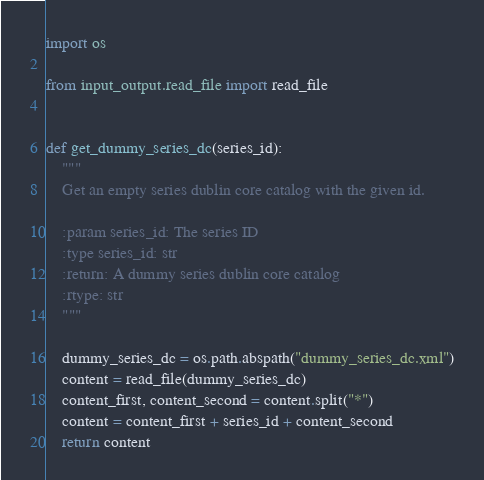<code> <loc_0><loc_0><loc_500><loc_500><_Python_>import os

from input_output.read_file import read_file


def get_dummy_series_dc(series_id):
    """
    Get an empty series dublin core catalog with the given id.

    :param series_id: The series ID
    :type series_id: str
    :return: A dummy series dublin core catalog
    :rtype: str
    """

    dummy_series_dc = os.path.abspath("dummy_series_dc.xml")
    content = read_file(dummy_series_dc)
    content_first, content_second = content.split("*")
    content = content_first + series_id + content_second
    return content
</code> 